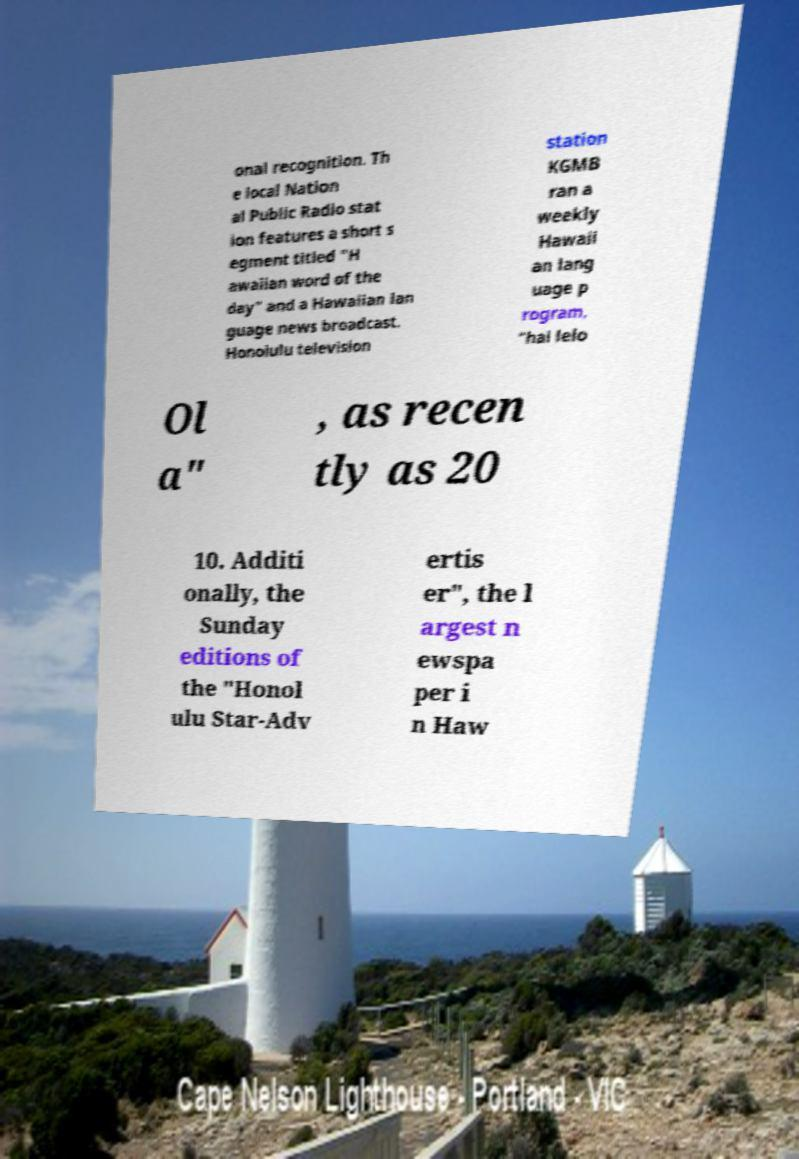Can you read and provide the text displayed in the image?This photo seems to have some interesting text. Can you extract and type it out for me? onal recognition. Th e local Nation al Public Radio stat ion features a short s egment titled "H awaiian word of the day" and a Hawaiian lan guage news broadcast. Honolulu television station KGMB ran a weekly Hawaii an lang uage p rogram, "hai lelo Ol a" , as recen tly as 20 10. Additi onally, the Sunday editions of the "Honol ulu Star-Adv ertis er", the l argest n ewspa per i n Haw 